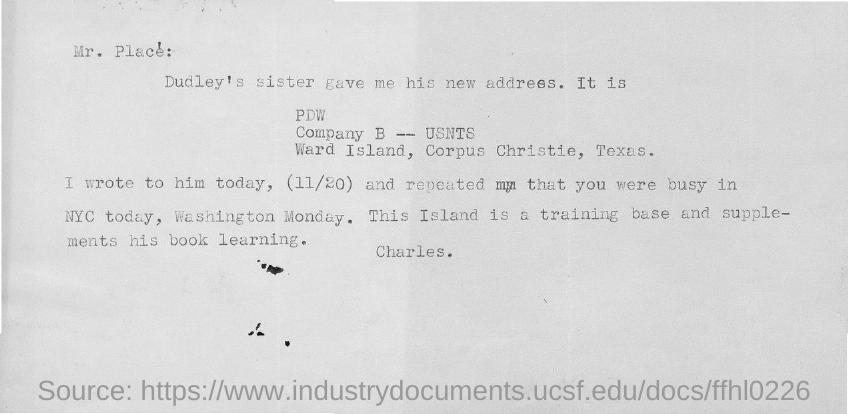What is the date mentioned in the document?
Offer a terse response. (11/20). 